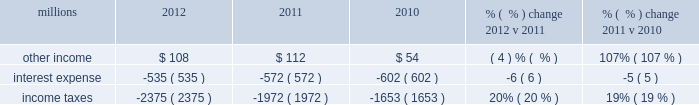Maintenance and contract expenses incurred by our subsidiaries for external transportation services ) ; materials used to maintain the railroad 2019s lines , structures , and equipment ; costs of operating facilities jointly used by uprr and other railroads ; transportation and lodging for train crew employees ; trucking and contracting costs for intermodal containers ; leased automobile maintenance expenses ; and tools and supplies .
Expenses for contract services increased $ 103 million in 2012 versus 2011 , primarily due to increased demand for transportation services purchased by our logistics subsidiaries for their customers and additional costs for repair and maintenance of locomotives and freight cars .
Expenses for contract services increased $ 106 million in 2011 versus 2010 , driven by volume-related external transportation services incurred by our subsidiaries , and various other types of contractual services , including flood-related repairs , mitigation and improvements .
Volume-related crew transportation and lodging costs , as well as expenses associated with jointly owned operating facilities , also increased costs compared to 2010 .
In addition , an increase in locomotive maintenance materials used to prepare a portion of our locomotive fleet for return to active service due to increased volume and additional capacity for weather related issues and warranty expirations increased expenses in 2011 .
Depreciation 2013 the majority of depreciation relates to road property , including rail , ties , ballast , and other track material .
A higher depreciable asset base , reflecting ongoing capital spending , increased depreciation expense in 2012 compared to 2011 .
A higher depreciable asset base , reflecting ongoing capital spending , increased depreciation expense in 2011 compared to 2010 .
Higher depreciation rates for rail and other track material also contributed to the increase .
The higher rates , which became effective january 1 , 2011 , resulted primarily from increased track usage ( based on higher gross ton-miles in 2010 ) .
Equipment and other rents 2013 equipment and other rents expense primarily includes rental expense that the railroad pays for freight cars owned by other railroads or private companies ; freight car , intermodal , and locomotive leases ; and office and other rent expenses .
Increased automotive and intermodal shipments , partially offset by improved car-cycle times , drove an increase in our short-term freight car rental expense in 2012 .
Conversely , lower locomotive lease expense partially offset the higher freight car rental expense .
Costs increased in 2011 versus 2010 as higher short-term freight car rental expense and container lease expense offset lower freight car and locomotive lease expense .
Other 2013 other expenses include personal injury , freight and property damage , destruction of equipment , insurance , environmental , bad debt , state and local taxes , utilities , telephone and cellular , employee travel , computer software , and other general expenses .
Other costs in 2012 were slightly higher than 2011 primarily due to higher property taxes .
Despite continual improvement in our safety experience and lower estimated annual costs , personal injury expense increased in 2012 compared to 2011 , as the liability reduction resulting from historical claim experience was less than the reduction in 2011 .
Higher property taxes , casualty costs associated with destroyed equipment , damaged freight and property and environmental costs increased other costs in 2011 compared to 2010 .
A one-time payment of $ 45 million in the first quarter of 2010 related to a transaction with csxi and continued improvement in our safety performance and lower estimated liability for personal injury , which reduced our personal injury expense year-over-year , partially offset increases in other costs .
Non-operating items millions 2012 2011 2010 % (  % ) change 2012 v 2011 % (  % ) change 2011 v 2010 .
Other income 2013 other income decreased in 2012 versus 2011 due to lower gains from real estate sales and higher environmental costs associated with non-operating properties , partially offset by an interest payment from a tax refund. .
What was the change in other income from 2010 to 2011 in millions? 
Computations: (112 - 54)
Answer: 58.0. 